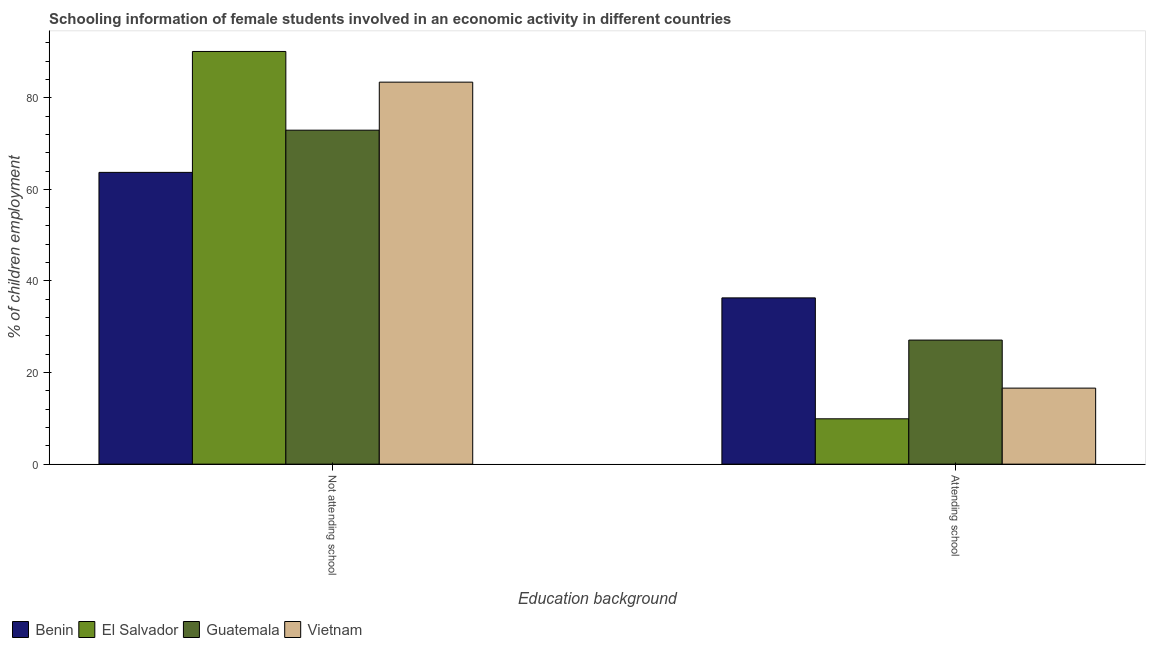How many different coloured bars are there?
Offer a terse response. 4. Are the number of bars per tick equal to the number of legend labels?
Provide a short and direct response. Yes. Are the number of bars on each tick of the X-axis equal?
Your answer should be very brief. Yes. How many bars are there on the 2nd tick from the left?
Offer a terse response. 4. How many bars are there on the 1st tick from the right?
Your answer should be compact. 4. What is the label of the 1st group of bars from the left?
Provide a succinct answer. Not attending school. What is the percentage of employed females who are not attending school in Benin?
Your answer should be very brief. 63.7. Across all countries, what is the maximum percentage of employed females who are not attending school?
Provide a short and direct response. 90.1. Across all countries, what is the minimum percentage of employed females who are attending school?
Provide a succinct answer. 9.9. In which country was the percentage of employed females who are not attending school maximum?
Keep it short and to the point. El Salvador. In which country was the percentage of employed females who are not attending school minimum?
Provide a succinct answer. Benin. What is the total percentage of employed females who are attending school in the graph?
Your response must be concise. 89.89. What is the difference between the percentage of employed females who are attending school in El Salvador and that in Benin?
Ensure brevity in your answer.  -26.4. What is the difference between the percentage of employed females who are not attending school in Vietnam and the percentage of employed females who are attending school in Benin?
Your answer should be compact. 47.1. What is the average percentage of employed females who are attending school per country?
Your response must be concise. 22.47. What is the difference between the percentage of employed females who are attending school and percentage of employed females who are not attending school in Guatemala?
Give a very brief answer. -45.82. In how many countries, is the percentage of employed females who are not attending school greater than 12 %?
Your answer should be compact. 4. What is the ratio of the percentage of employed females who are not attending school in Vietnam to that in El Salvador?
Keep it short and to the point. 0.93. Is the percentage of employed females who are attending school in El Salvador less than that in Benin?
Keep it short and to the point. Yes. In how many countries, is the percentage of employed females who are attending school greater than the average percentage of employed females who are attending school taken over all countries?
Give a very brief answer. 2. What does the 3rd bar from the left in Not attending school represents?
Provide a succinct answer. Guatemala. What does the 4th bar from the right in Attending school represents?
Offer a very short reply. Benin. How many bars are there?
Your response must be concise. 8. How many countries are there in the graph?
Keep it short and to the point. 4. What is the difference between two consecutive major ticks on the Y-axis?
Keep it short and to the point. 20. Does the graph contain any zero values?
Give a very brief answer. No. Where does the legend appear in the graph?
Your answer should be compact. Bottom left. What is the title of the graph?
Offer a terse response. Schooling information of female students involved in an economic activity in different countries. Does "Cameroon" appear as one of the legend labels in the graph?
Provide a short and direct response. No. What is the label or title of the X-axis?
Offer a terse response. Education background. What is the label or title of the Y-axis?
Your answer should be very brief. % of children employment. What is the % of children employment of Benin in Not attending school?
Your answer should be very brief. 63.7. What is the % of children employment in El Salvador in Not attending school?
Provide a short and direct response. 90.1. What is the % of children employment in Guatemala in Not attending school?
Provide a short and direct response. 72.91. What is the % of children employment in Vietnam in Not attending school?
Provide a short and direct response. 83.4. What is the % of children employment of Benin in Attending school?
Your response must be concise. 36.3. What is the % of children employment of Guatemala in Attending school?
Ensure brevity in your answer.  27.09. Across all Education background, what is the maximum % of children employment in Benin?
Your answer should be compact. 63.7. Across all Education background, what is the maximum % of children employment in El Salvador?
Give a very brief answer. 90.1. Across all Education background, what is the maximum % of children employment of Guatemala?
Ensure brevity in your answer.  72.91. Across all Education background, what is the maximum % of children employment in Vietnam?
Offer a very short reply. 83.4. Across all Education background, what is the minimum % of children employment of Benin?
Keep it short and to the point. 36.3. Across all Education background, what is the minimum % of children employment of El Salvador?
Ensure brevity in your answer.  9.9. Across all Education background, what is the minimum % of children employment of Guatemala?
Your answer should be compact. 27.09. Across all Education background, what is the minimum % of children employment of Vietnam?
Ensure brevity in your answer.  16.6. What is the total % of children employment in Benin in the graph?
Keep it short and to the point. 100. What is the difference between the % of children employment of Benin in Not attending school and that in Attending school?
Your answer should be very brief. 27.4. What is the difference between the % of children employment of El Salvador in Not attending school and that in Attending school?
Your answer should be very brief. 80.2. What is the difference between the % of children employment in Guatemala in Not attending school and that in Attending school?
Your answer should be very brief. 45.82. What is the difference between the % of children employment in Vietnam in Not attending school and that in Attending school?
Your response must be concise. 66.8. What is the difference between the % of children employment of Benin in Not attending school and the % of children employment of El Salvador in Attending school?
Your answer should be compact. 53.8. What is the difference between the % of children employment of Benin in Not attending school and the % of children employment of Guatemala in Attending school?
Your response must be concise. 36.61. What is the difference between the % of children employment of Benin in Not attending school and the % of children employment of Vietnam in Attending school?
Your answer should be compact. 47.1. What is the difference between the % of children employment in El Salvador in Not attending school and the % of children employment in Guatemala in Attending school?
Give a very brief answer. 63.01. What is the difference between the % of children employment in El Salvador in Not attending school and the % of children employment in Vietnam in Attending school?
Provide a succinct answer. 73.5. What is the difference between the % of children employment in Guatemala in Not attending school and the % of children employment in Vietnam in Attending school?
Provide a succinct answer. 56.31. What is the average % of children employment of El Salvador per Education background?
Provide a short and direct response. 50. What is the difference between the % of children employment in Benin and % of children employment in El Salvador in Not attending school?
Your answer should be very brief. -26.4. What is the difference between the % of children employment in Benin and % of children employment in Guatemala in Not attending school?
Your answer should be very brief. -9.21. What is the difference between the % of children employment in Benin and % of children employment in Vietnam in Not attending school?
Give a very brief answer. -19.7. What is the difference between the % of children employment in El Salvador and % of children employment in Guatemala in Not attending school?
Provide a succinct answer. 17.19. What is the difference between the % of children employment of El Salvador and % of children employment of Vietnam in Not attending school?
Provide a short and direct response. 6.7. What is the difference between the % of children employment in Guatemala and % of children employment in Vietnam in Not attending school?
Make the answer very short. -10.49. What is the difference between the % of children employment in Benin and % of children employment in El Salvador in Attending school?
Offer a very short reply. 26.4. What is the difference between the % of children employment in Benin and % of children employment in Guatemala in Attending school?
Keep it short and to the point. 9.21. What is the difference between the % of children employment in Benin and % of children employment in Vietnam in Attending school?
Keep it short and to the point. 19.7. What is the difference between the % of children employment of El Salvador and % of children employment of Guatemala in Attending school?
Provide a short and direct response. -17.19. What is the difference between the % of children employment of El Salvador and % of children employment of Vietnam in Attending school?
Provide a short and direct response. -6.7. What is the difference between the % of children employment in Guatemala and % of children employment in Vietnam in Attending school?
Offer a very short reply. 10.49. What is the ratio of the % of children employment of Benin in Not attending school to that in Attending school?
Give a very brief answer. 1.75. What is the ratio of the % of children employment in El Salvador in Not attending school to that in Attending school?
Ensure brevity in your answer.  9.1. What is the ratio of the % of children employment in Guatemala in Not attending school to that in Attending school?
Make the answer very short. 2.69. What is the ratio of the % of children employment in Vietnam in Not attending school to that in Attending school?
Your answer should be compact. 5.02. What is the difference between the highest and the second highest % of children employment in Benin?
Your answer should be very brief. 27.4. What is the difference between the highest and the second highest % of children employment in El Salvador?
Offer a terse response. 80.2. What is the difference between the highest and the second highest % of children employment of Guatemala?
Your answer should be very brief. 45.82. What is the difference between the highest and the second highest % of children employment in Vietnam?
Ensure brevity in your answer.  66.8. What is the difference between the highest and the lowest % of children employment of Benin?
Offer a very short reply. 27.4. What is the difference between the highest and the lowest % of children employment in El Salvador?
Your response must be concise. 80.2. What is the difference between the highest and the lowest % of children employment in Guatemala?
Give a very brief answer. 45.82. What is the difference between the highest and the lowest % of children employment in Vietnam?
Ensure brevity in your answer.  66.8. 